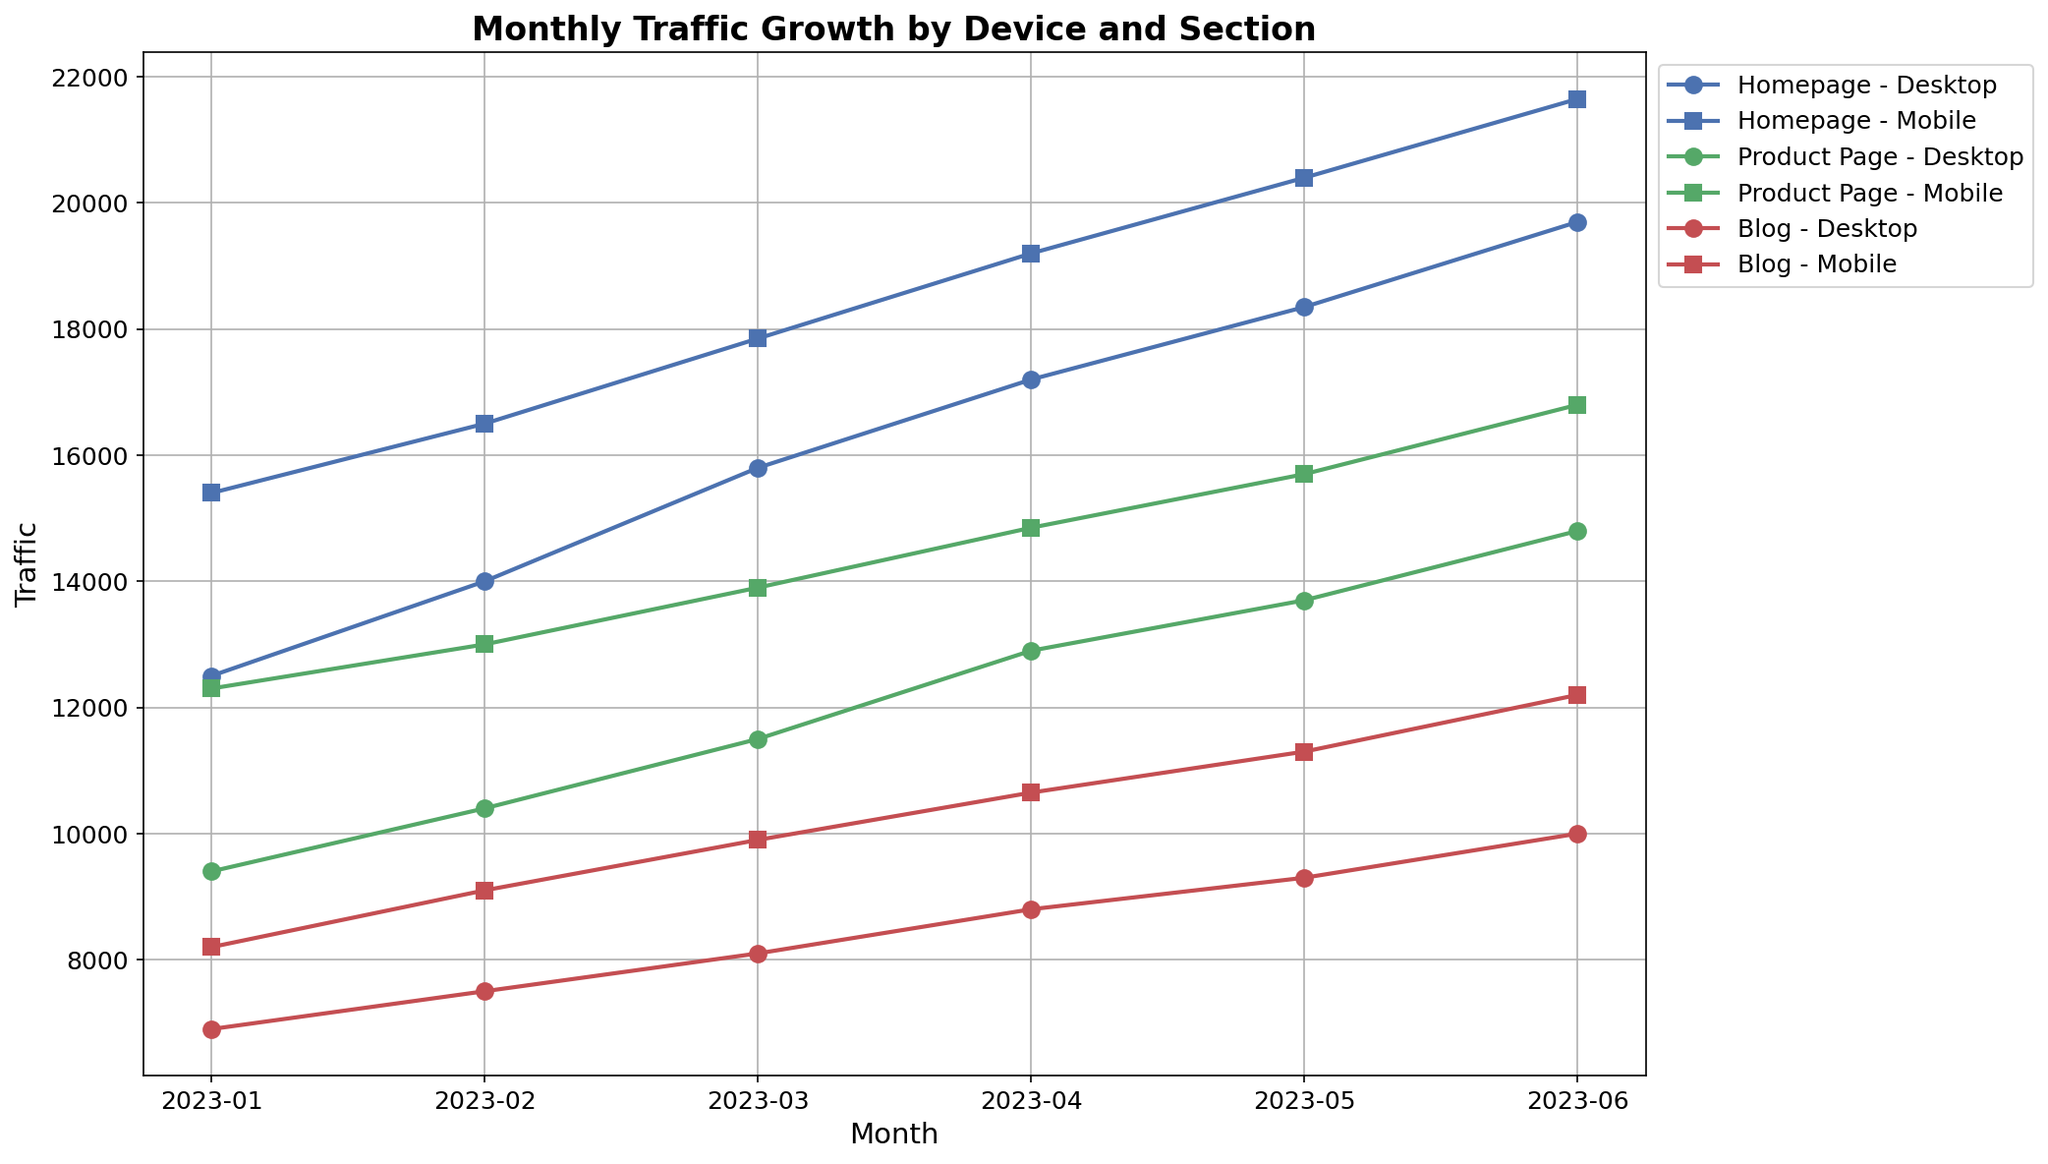Which section and device type had the highest traffic in June 2023? To answer this question, look at the traffic values for all sections (Homepage, Product Page, Blog) and device types (Desktop, Mobile) for June 2023. The highest traffic value is for the Homepage on Mobile with 21650.
Answer: Homepage - Mobile How is the traffic growth trend for Desktop devices on the Product Page from January to June 2023? Examine the line plot representing the Desktop devices on the Product Page, which is marked with a specific marker and color. The traffic growth increases every month from January (9400) to June (14800).
Answer: Increasing What's the average traffic for the Blog section on Mobile devices from January to June 2023? Sum the traffic values of the Blog section on Mobile devices for each month from January to June (8200 + 9100 + 9900 + 10650 + 11300 + 12200) = 61150. Then, divide by the number of months (6). The average traffic is 61150/6 = 10191.67.
Answer: 10191.67 Which month saw the largest difference in traffic between Mobile and Desktop users on the Homepage? Calculate the difference in traffic between Mobile and Desktop users on the Homepage for each month. Identify the month with the highest difference: 
- January: 15400 - 12500 = 2900
- February: 16500 - 14000 = 2500
- March: 17850 - 15800 = 2050
- April: 19200 - 17200 = 2000
- May: 20400 - 18350 = 2050
- June: 21650 - 19700 = 1950
January has the largest difference with 2900.
Answer: January In which month did the Product Page section on Mobile devices first surpass 15000 in traffic? Check the traffic values of the Product Page section on Mobile devices month by month. The traffic surpasses 15000 in May 2023, with a value of 15700.
Answer: May 2023 Between the Homepage and Blog sections, which one showed a more consistent traffic increase for Desktop devices over the period? For Homepage Desktop, the traffic values are: 12500, 14000, 15800, 17200, 18350, 19700 (consistently increasing each month). For Blog Desktop, the traffic values are: 6900, 7500, 8100, 8800, 9300, 10000 (consistently increasing each month). Both show consistent increases, but the Homepage has a larger and more steady increase.
Answer: Homepage What is the ratio of Mobile to Desktop traffic for the Blog section in June 2023? The traffic for the Blog section in June 2023 is 12200 for Mobile and 10000 for Desktop. The ratio is 12200 / 10000 = 1.22.
Answer: 1.22 Which section has the smallest traffic discrepancy between Desktop and Mobile devices in May 2023? Calculate the discrepancy for each section in May 2023: 
- Homepage: 20400 - 18350 = 2050
- Product Page: 15700 - 13700 = 2000
- Blog: 11300 - 9300 = 2000
The Product Page and Blog sections have the smallest discrepancy, both with a difference of 2000.
Answer: Product Page and Blog 